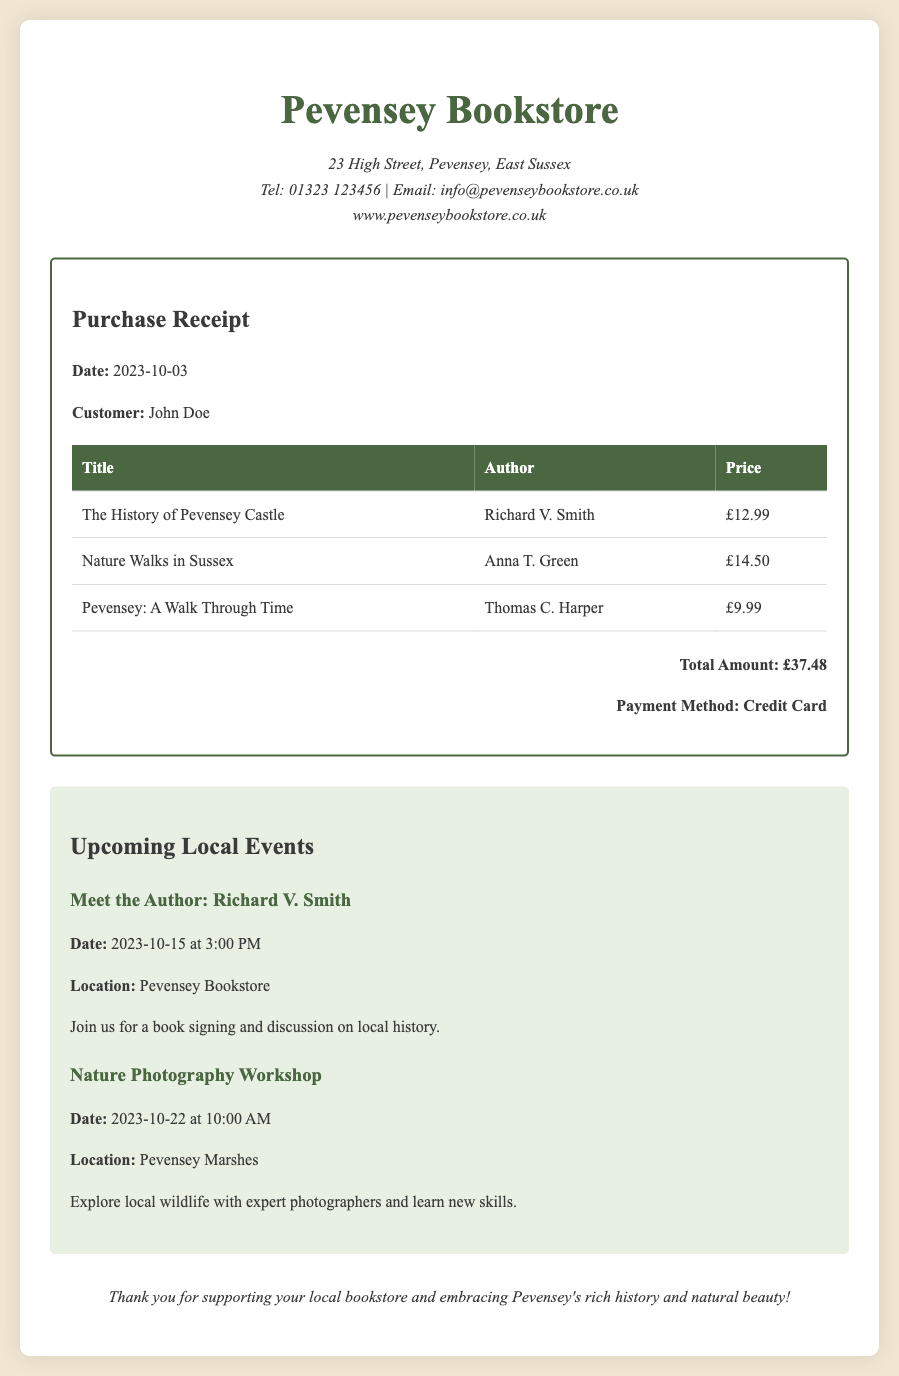What is the purchase date? The purchase date is clearly mentioned in the receipt section as the date of the transaction.
Answer: 2023-10-03 Who is the author of "The History of Pevensey Castle"? The document lists the authors next to each book title in the receipt section.
Answer: Richard V. Smith What is the total amount spent? The total amount is calculated and stated at the bottom of the receipt.
Answer: £37.48 When is the "Meet the Author: Richard V. Smith" event scheduled? The document lists upcoming local events with their respective dates and times.
Answer: 2023-10-15 at 3:00 PM What is the location of the "Nature Photography Workshop"? The event details included in the document provide information on where the event will take place.
Answer: Pevensey Marshes How many books were purchased in total? The number of book entries in the purchase receipt gives the answer.
Answer: 3 What payment method was used for the purchase? The payment method for the transaction is stated in the receipt section.
Answer: Credit Card What is the title of the second book? The titles of the books are listed in the receipt table, and the second one can be identified directly.
Answer: Nature Walks in Sussex 